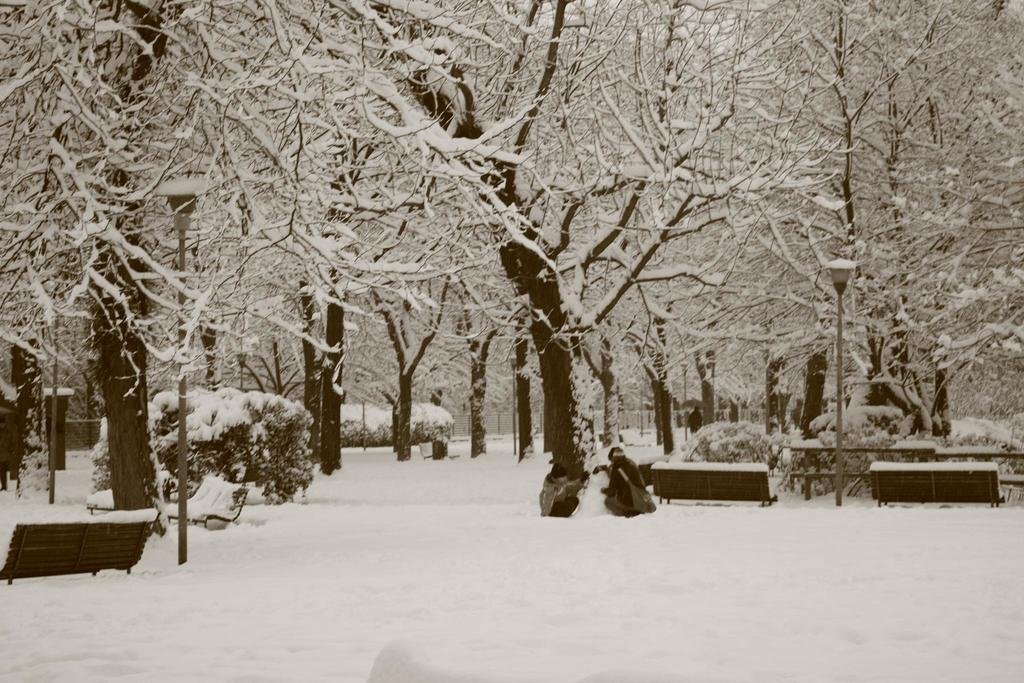What type of vegetation is present in the image? There are trees in the image. What is the condition of the trees in the image? The trees have snow on them. Can you describe the person in the image? There is a person in the image, and they are holding a bag. How does the person in the image support their sleep while holding the bag? There is no indication in the image that the person is sleeping or requires support for sleep. 